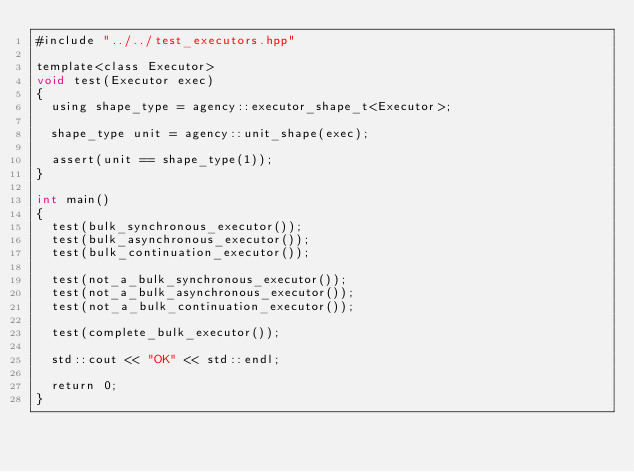Convert code to text. <code><loc_0><loc_0><loc_500><loc_500><_Cuda_>#include "../../test_executors.hpp"

template<class Executor>
void test(Executor exec)
{
  using shape_type = agency::executor_shape_t<Executor>;

  shape_type unit = agency::unit_shape(exec);

  assert(unit == shape_type(1));
}

int main()
{
  test(bulk_synchronous_executor());
  test(bulk_asynchronous_executor());
  test(bulk_continuation_executor());

  test(not_a_bulk_synchronous_executor());
  test(not_a_bulk_asynchronous_executor());
  test(not_a_bulk_continuation_executor());

  test(complete_bulk_executor());

  std::cout << "OK" << std::endl;

  return 0;
}

</code> 